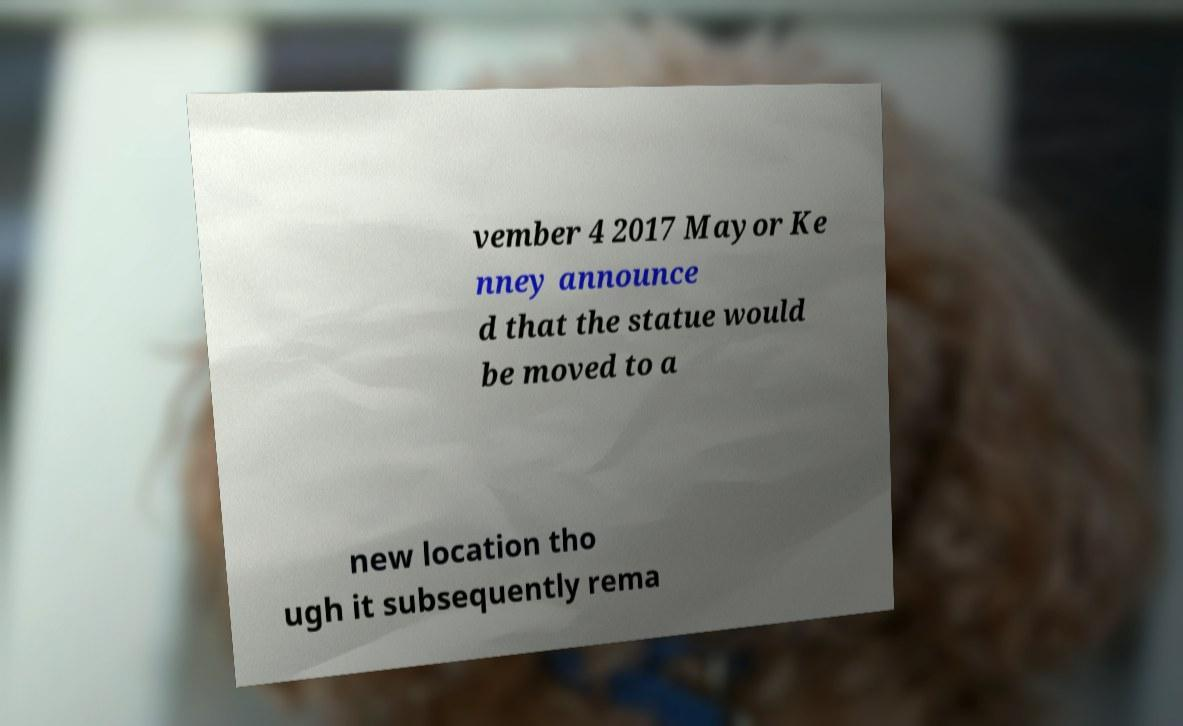Can you accurately transcribe the text from the provided image for me? vember 4 2017 Mayor Ke nney announce d that the statue would be moved to a new location tho ugh it subsequently rema 